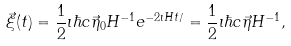<formula> <loc_0><loc_0><loc_500><loc_500>\vec { \xi } ( t ) = \frac { 1 } { 2 } \imath \hbar { c } \vec { \eta } _ { 0 } H ^ { - 1 } e ^ { - 2 \imath H t / } = \frac { 1 } { 2 } \imath \hbar { c } \vec { \eta } H ^ { - 1 } ,</formula> 